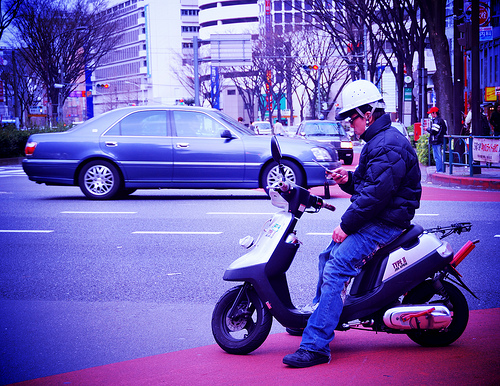How many scooters are there? 1 